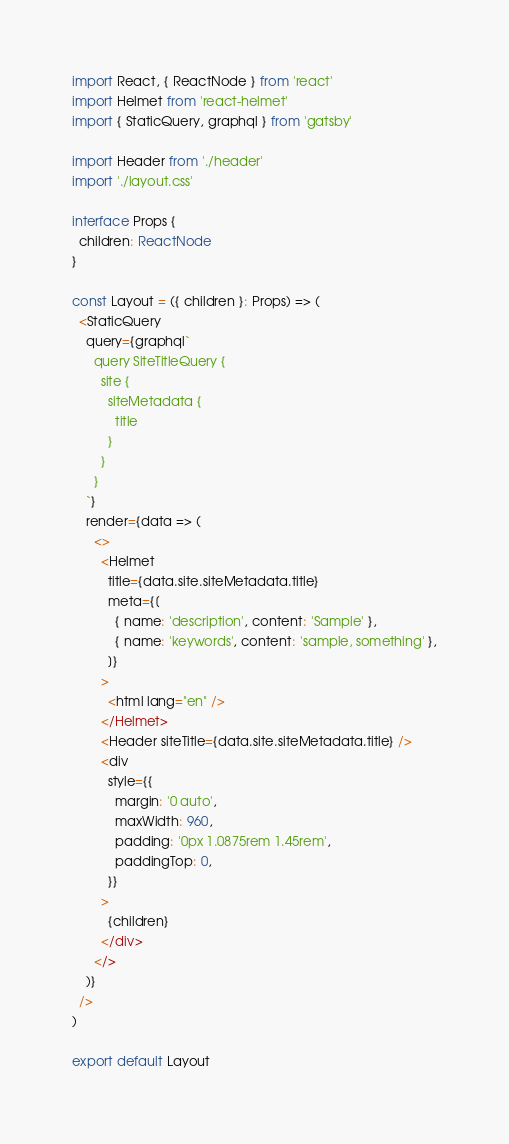Convert code to text. <code><loc_0><loc_0><loc_500><loc_500><_TypeScript_>import React, { ReactNode } from 'react'
import Helmet from 'react-helmet'
import { StaticQuery, graphql } from 'gatsby'

import Header from './header'
import './layout.css'

interface Props {
  children: ReactNode
}

const Layout = ({ children }: Props) => (
  <StaticQuery
    query={graphql`
      query SiteTitleQuery {
        site {
          siteMetadata {
            title
          }
        }
      }
    `}
    render={data => (
      <>
        <Helmet
          title={data.site.siteMetadata.title}
          meta={[
            { name: 'description', content: 'Sample' },
            { name: 'keywords', content: 'sample, something' },
          ]}
        >
          <html lang="en" />
        </Helmet>
        <Header siteTitle={data.site.siteMetadata.title} />
        <div
          style={{
            margin: '0 auto',
            maxWidth: 960,
            padding: '0px 1.0875rem 1.45rem',
            paddingTop: 0,
          }}
        >
          {children}
        </div>
      </>
    )}
  />
)

export default Layout
</code> 